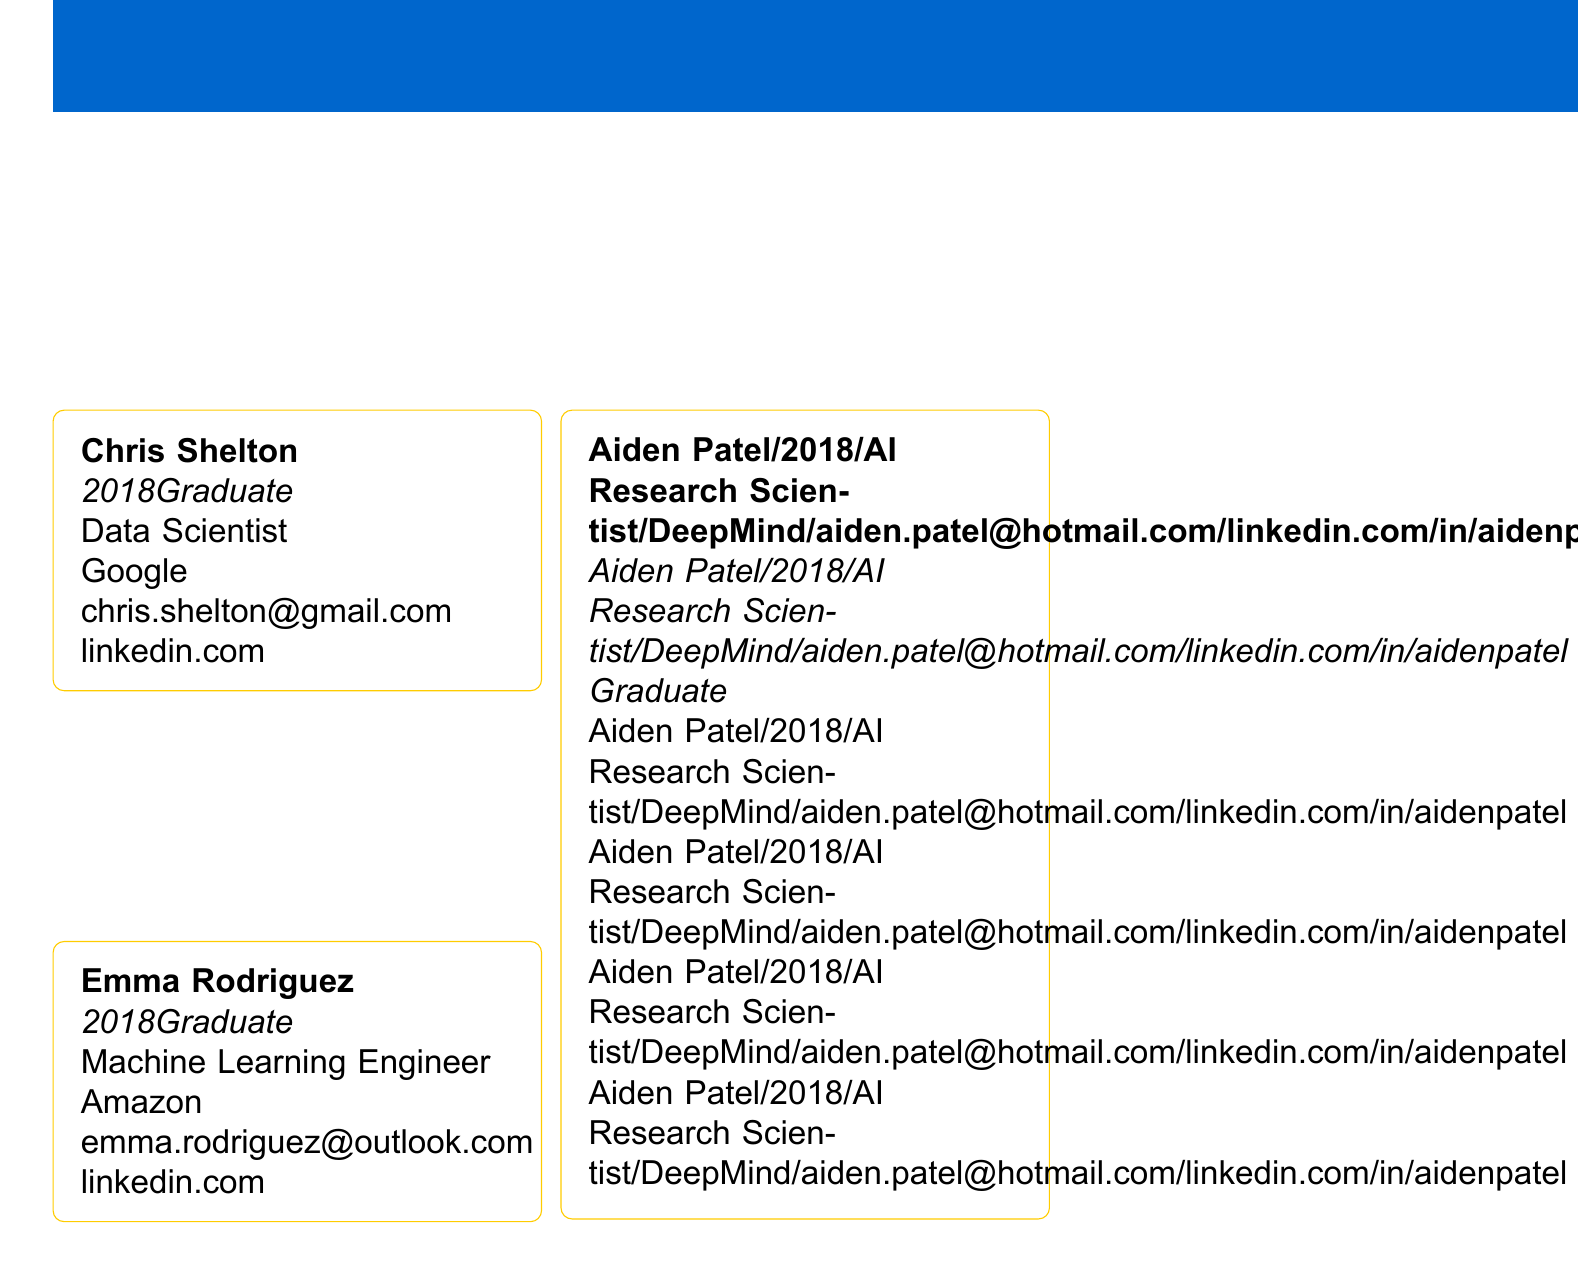What is the title of the document? The title of the document is mentioned at the top as the primary heading.
Answer: MSc Program Alumni Network Directory Who is the first alumnus listed in the directory? The first alumnus listed is shown on the first card in the directory.
Answer: Chris Shelton In what year did Emma Rodriguez graduate? The graduation year is indicated under each alumnus's name.
Answer: 2018 What is Chris Shelton's current position? The current position is provided in each alumnus's profile.
Answer: Data Scientist Which company does Aiden Patel work for? The company name is listed under each alumnus's current position.
Answer: DeepMind What email address is given for Emma Rodriguez? The email address is provided in her profile within the document.
Answer: emma.rodriguez@outlook.com How many alumni profiles are shown in the document? The total number of profiles can be counted from the entries available.
Answer: 3 What are two suggested networking tips mentioned in the document? The tips are listed under a specific section dedicated to networking advice.
Answer: Utilize LinkedIn to stay connected with fellow alumni, Attend annual alumni gatherings organized by the university What is the contact email for the Alumni Office? The contact email is given in the contact information section of the document.
Answer: alumni@university.edu 